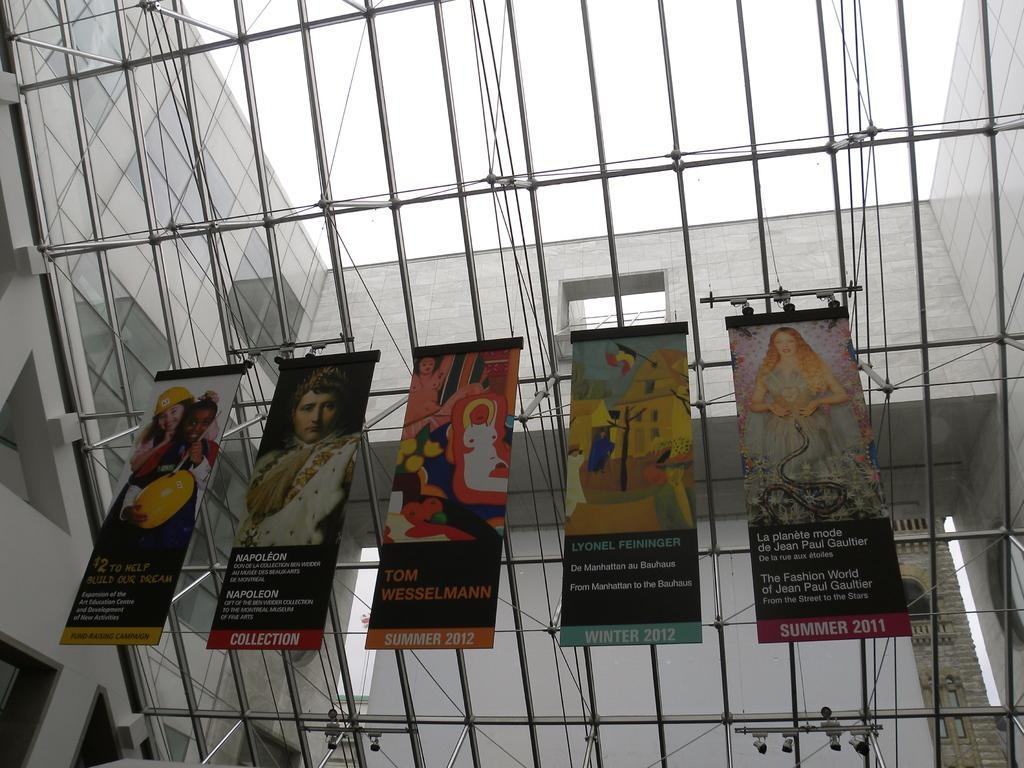How many banners are present in the image? There are five banners in the image. What can be found on the banners? There is text and pictures of people on the banners. What part of a building can be seen in the image? The internal structure of a building is visible in the image. What is visible in the background of the image? The sky is visible in the image. How many cats are sitting on the banners in the image? There are no cats present on the banners or in the image. What type of lawyer is depicted in the image? There is no lawyer depicted in the image; it features banners with text and pictures of people. 